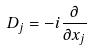Convert formula to latex. <formula><loc_0><loc_0><loc_500><loc_500>D _ { j } = - i \frac { \partial } { \partial x _ { j } }</formula> 